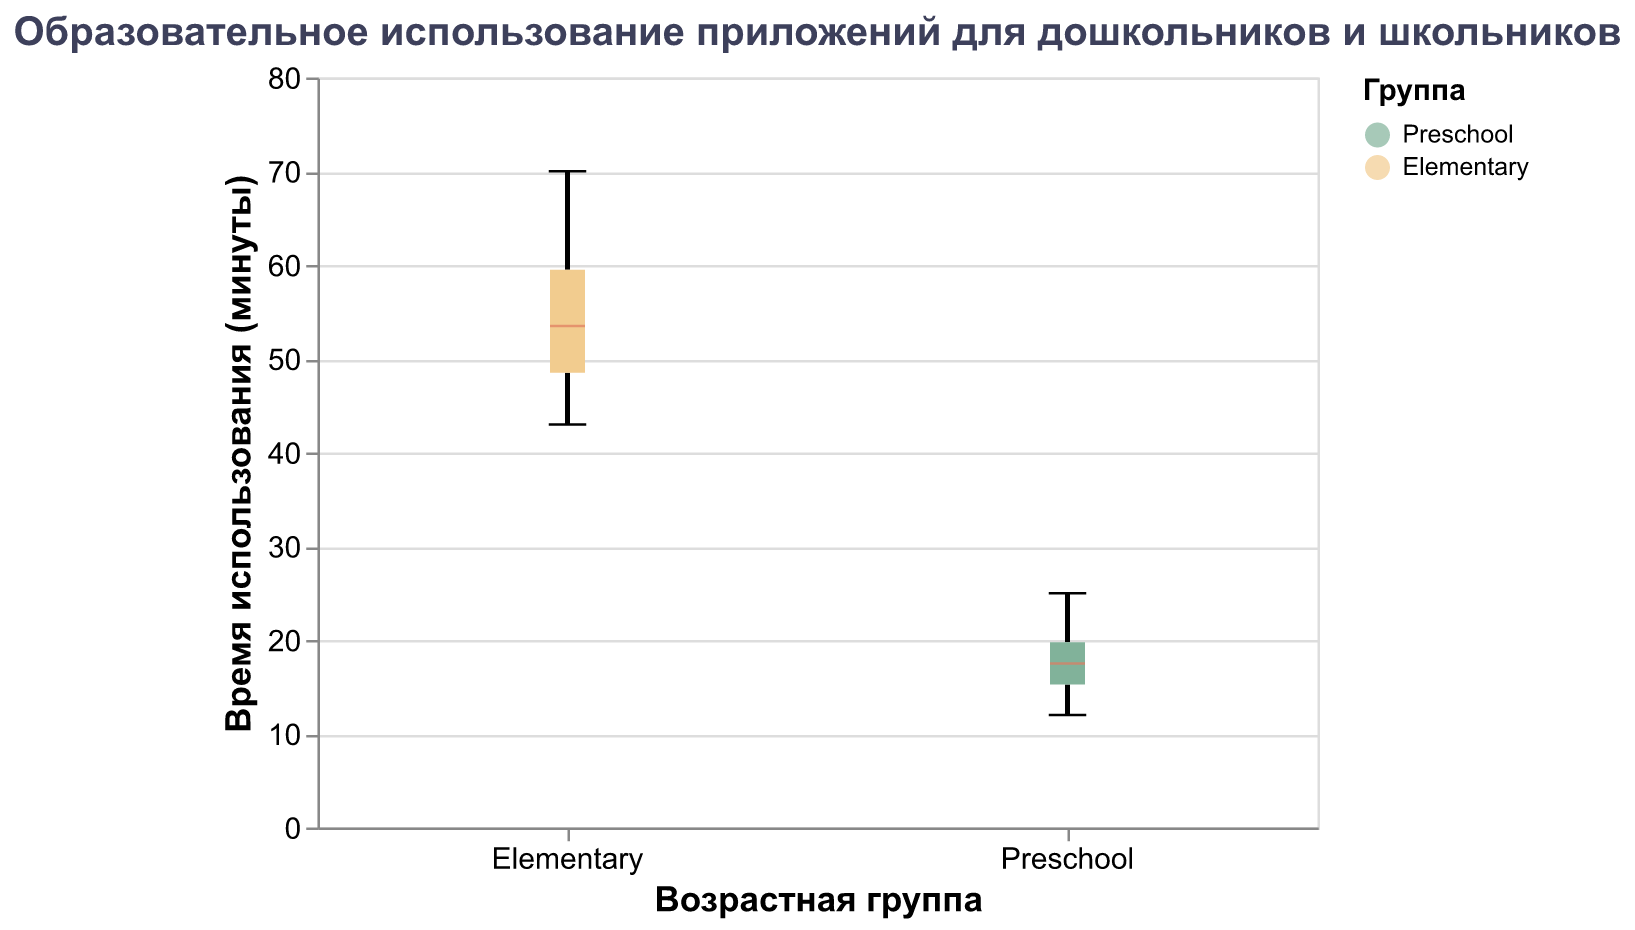What is the title of the plot? The title of the plot is located at the top and typically summarizes the main insight the plot is meant to convey. Here, the title is in Russian.
Answer: Образовательное использование приложений для дошкольников и школьников What is the age group with the highest median usage time? To find the age group with the highest median, look at the horizontal line inside each boxplot. The position of the line tells you the median value.
Answer: Elementary How many preschooler data points are there? Count the number of data points provided in the data list labeled "Preschool"
Answer: 10 What is the median usage time for elementary school children? Locate the horizontal line inside the boxplot for "Elementary" to determine the median value. This line represents the median usage time.
Answer: Approximately 52 minutes What is the range of usage times for preschoolers? The range is the difference between the maximum and minimum values in the "Preschool" group. Identify the top and bottom whiskers of the boxplot for this group.
Answer: 12 to 25 minutes Which age group has a greater spread of data? Compare the lengths of the boxes and the whiskers for both groups. The group with the longer box or whiskers has a greater spread.
Answer: Elementary What is the difference between the maximum usage time for preschoolers and elementary school children? Identify the top whiskers of both boxplots to find the maximum values and subtract the maximum preschool value from the maximum elementary value.
Answer: 45 minutes Which age group shows more variability in their data? The age group with a wider interquartile range (IQR) and longer whiskers indicates more variability. This can be inferred by visually examining the boxes and whiskers.
Answer: Elementary Is the average app usage time likely higher for preschoolers or elementary school children? Higher values on the y-axis for the boxplot (median and quartiles) suggest a higher average usage.
Answer: Elementary Are there any outliers in the data? Outliers would be marked points outside the whiskers of the boxplot. Identify if there are any such data points.
Answer: No 